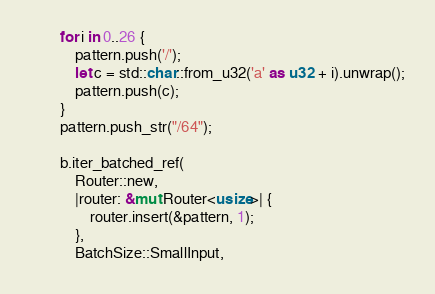<code> <loc_0><loc_0><loc_500><loc_500><_Rust_>        for i in 0..26 {
            pattern.push('/');
            let c = std::char::from_u32('a' as u32 + i).unwrap();
            pattern.push(c);
        }
        pattern.push_str("/64");

        b.iter_batched_ref(
            Router::new,
            |router: &mut Router<usize>| {
                router.insert(&pattern, 1);
            },
            BatchSize::SmallInput,</code> 